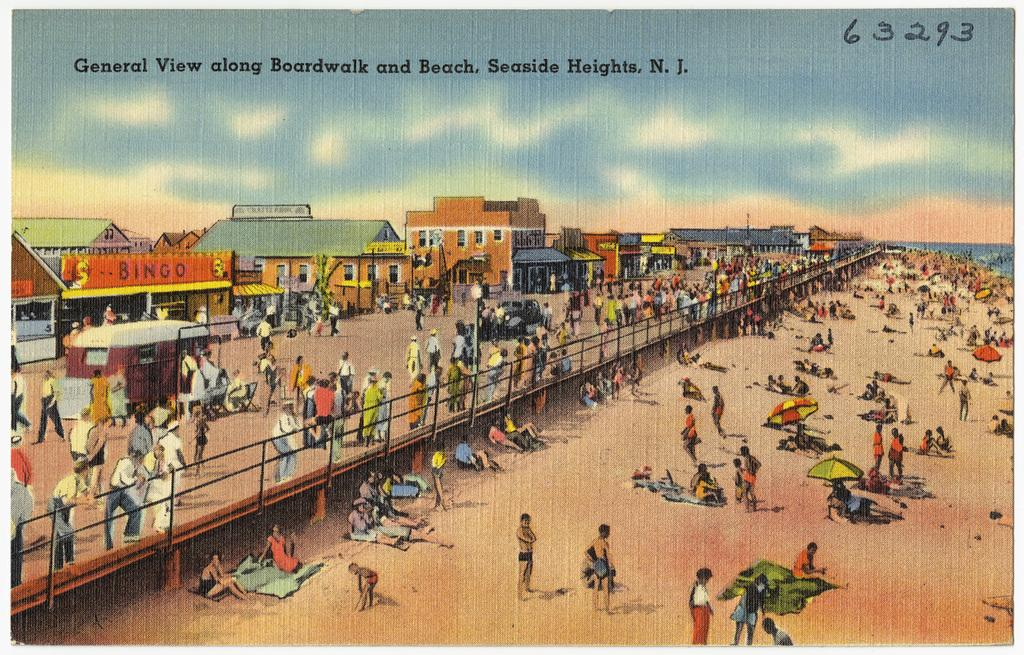Provide a one-sentence caption for the provided image. A postcard with a beach scene from New Jersey. 